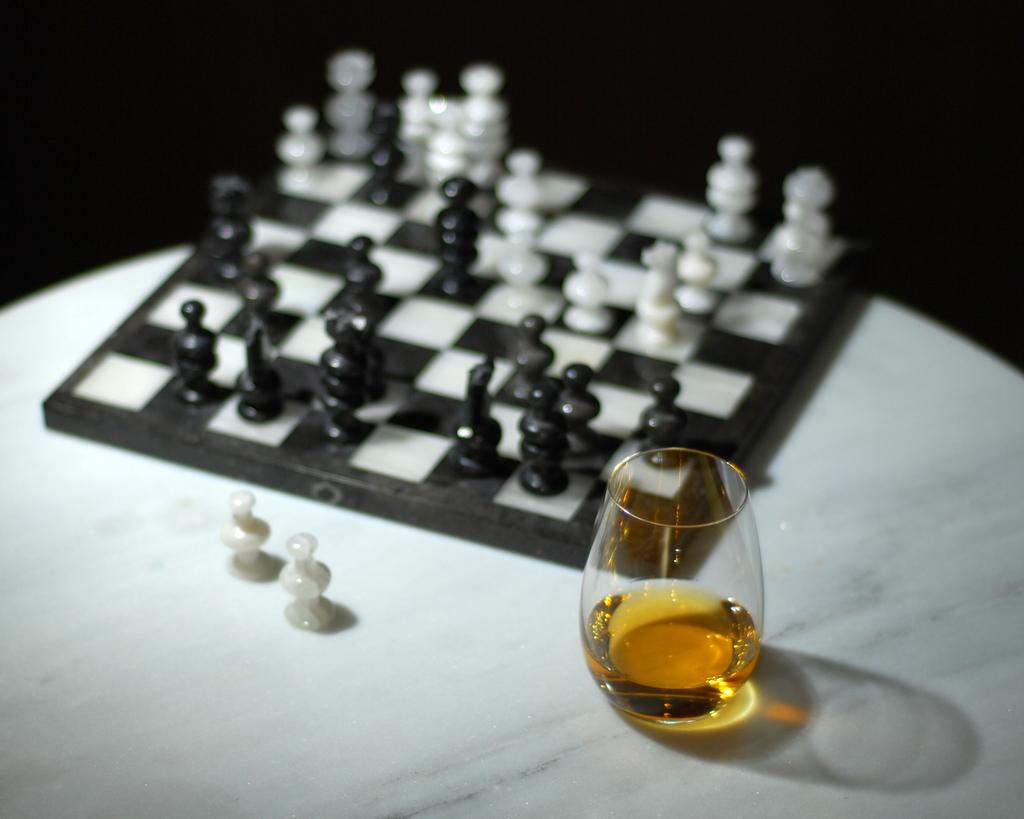What game is being played on the chess board in the image? The game being played on the chess board in the image is chess, as indicated by the presence of chess coins. What other objects can be seen in the image besides the chess board? There is a wine glass on a table in the image. How many feet are visible in the image? There are no feet visible in the image. What type of work is being done in the image? There is no indication of work being done in the image; it primarily features a chess board and a wine glass. 